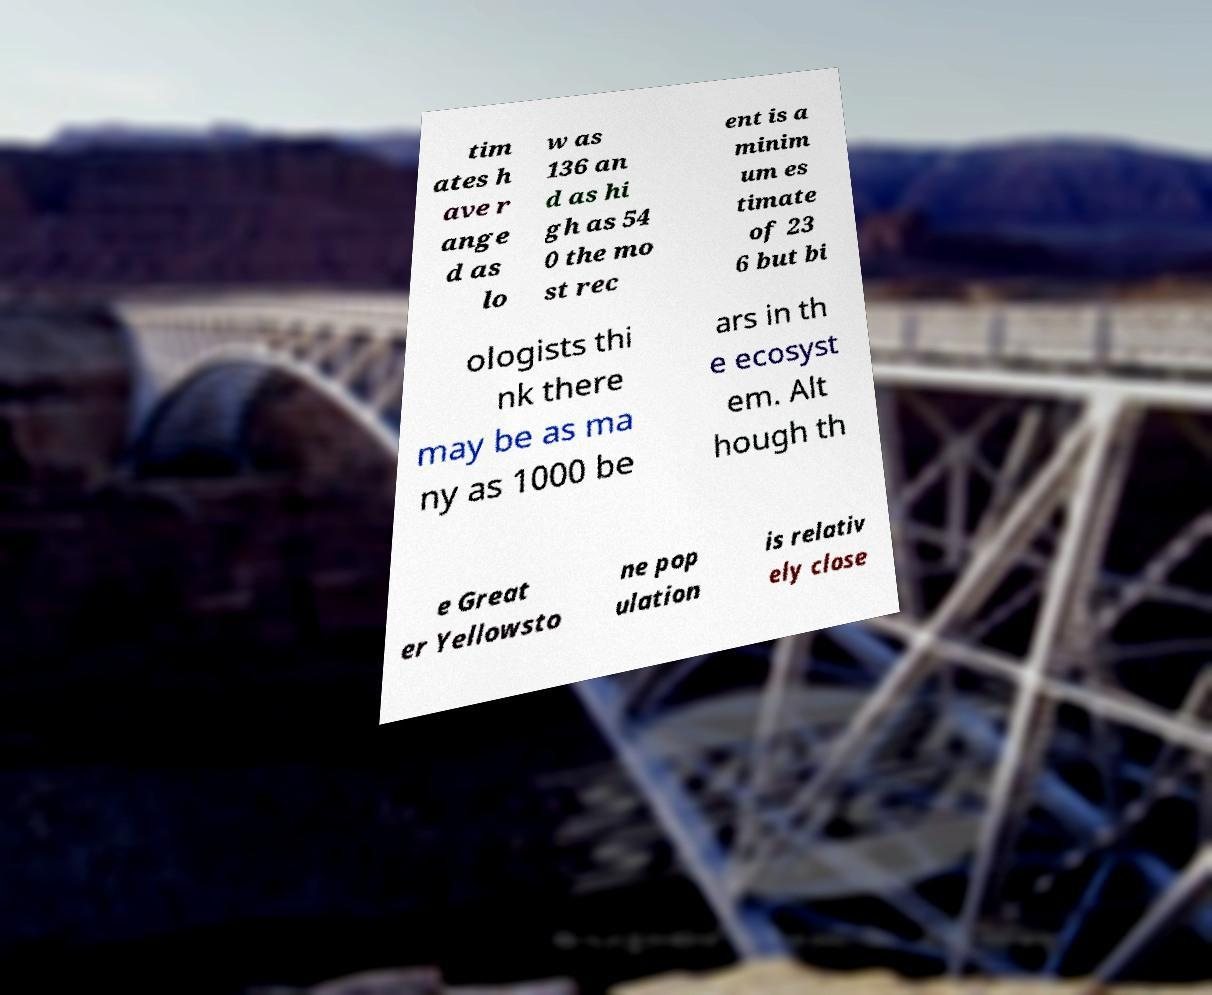Please identify and transcribe the text found in this image. tim ates h ave r ange d as lo w as 136 an d as hi gh as 54 0 the mo st rec ent is a minim um es timate of 23 6 but bi ologists thi nk there may be as ma ny as 1000 be ars in th e ecosyst em. Alt hough th e Great er Yellowsto ne pop ulation is relativ ely close 